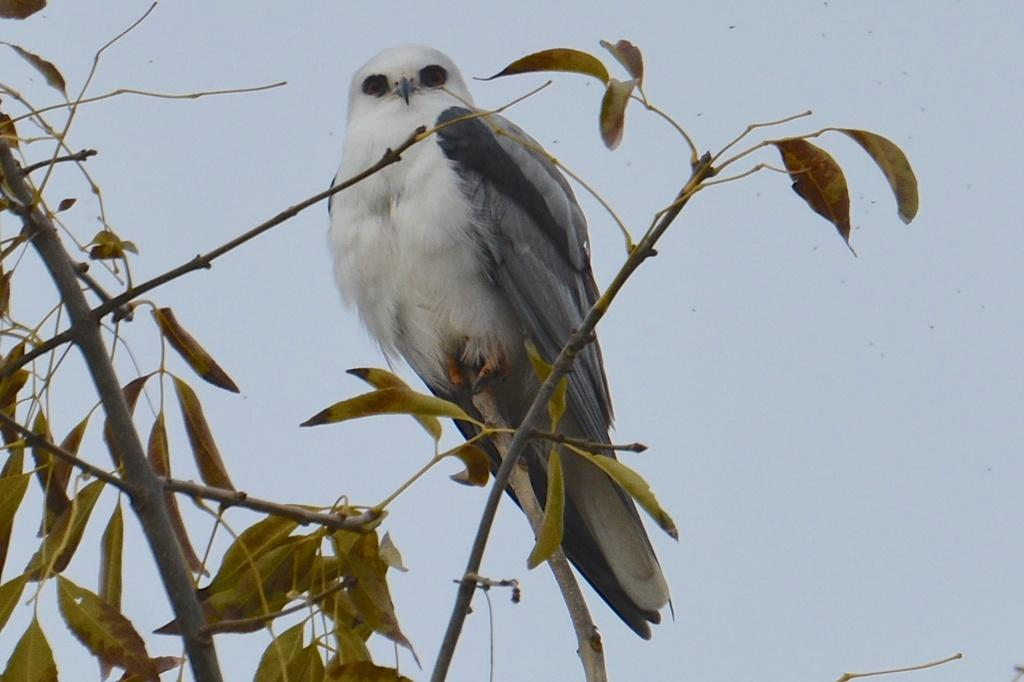What type of animal can be seen in the image? There is a bird in the image. Where is the bird located? The bird is on a branch in the image. What else can be seen in the image besides the bird? There are leaves and stems visible in the image. What can be seen in the background of the image? The sky is visible in the background of the image. What type of bead is the bird using to teach beginner knitting techniques in the image? There is no bead or knitting activity present in the image; it features a bird on a branch with leaves and stems. 